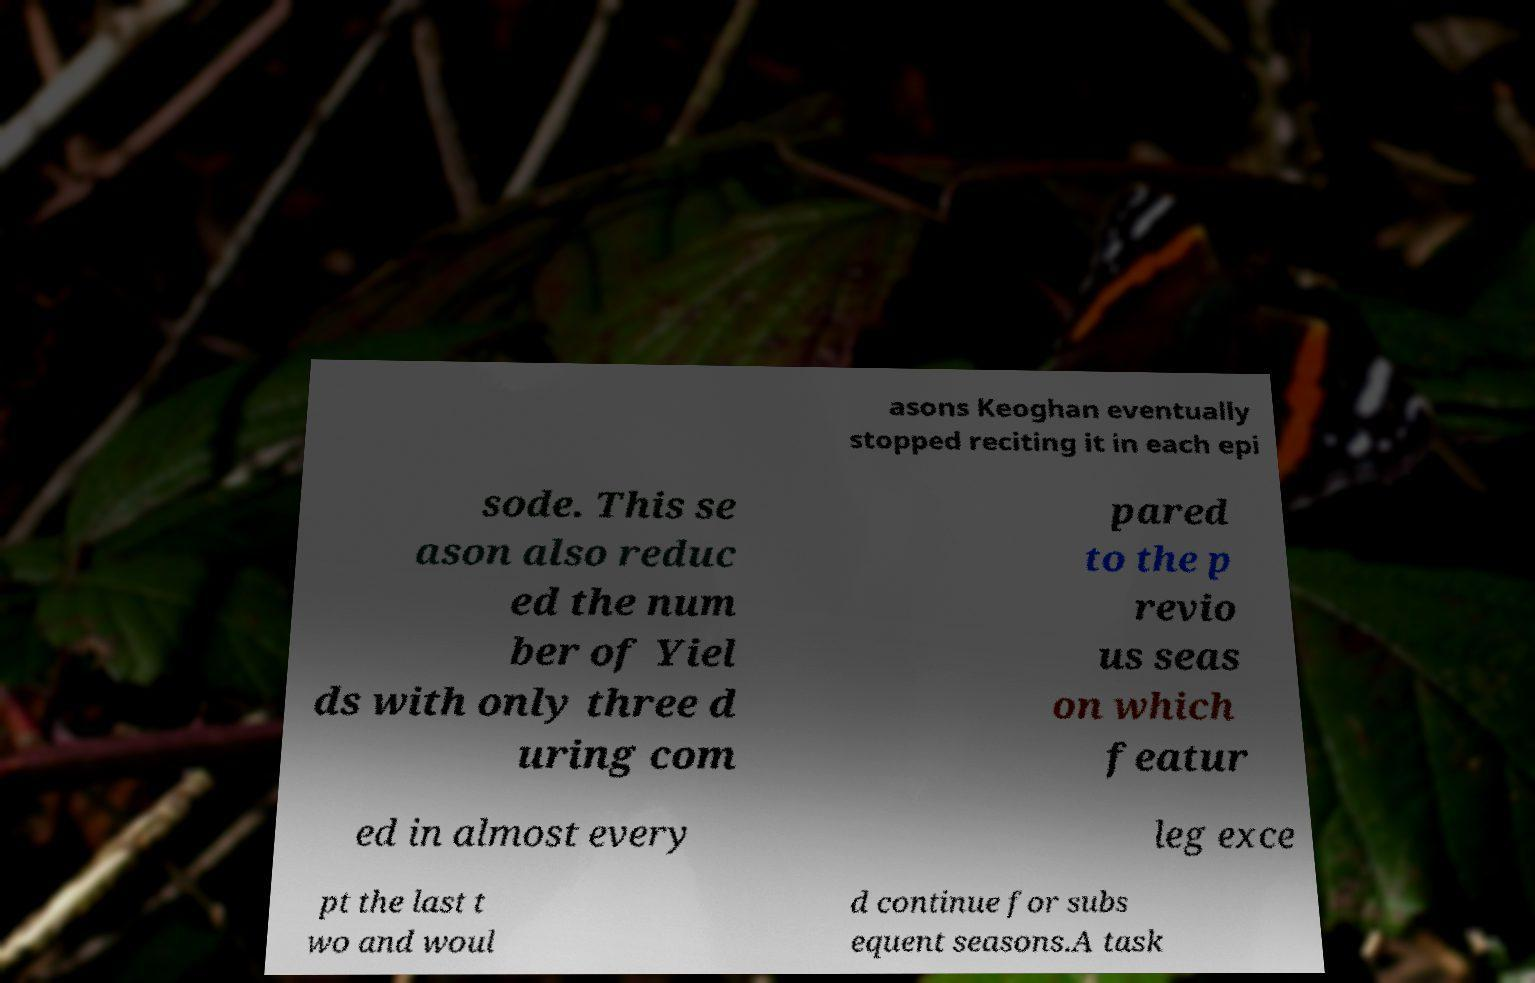Could you assist in decoding the text presented in this image and type it out clearly? asons Keoghan eventually stopped reciting it in each epi sode. This se ason also reduc ed the num ber of Yiel ds with only three d uring com pared to the p revio us seas on which featur ed in almost every leg exce pt the last t wo and woul d continue for subs equent seasons.A task 